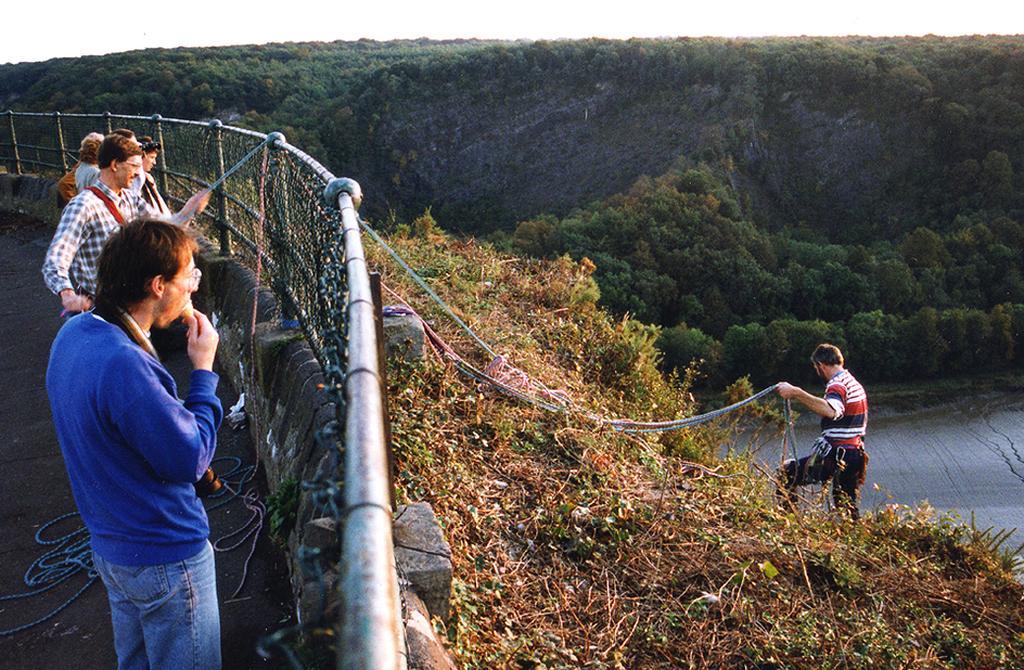Could you give a brief overview of what you see in this image? In the image there is a person climbing a mountain and there is a fence and behind the fence there are few people and among them,one person is helping the person with a rope and in the background there are many trees. 